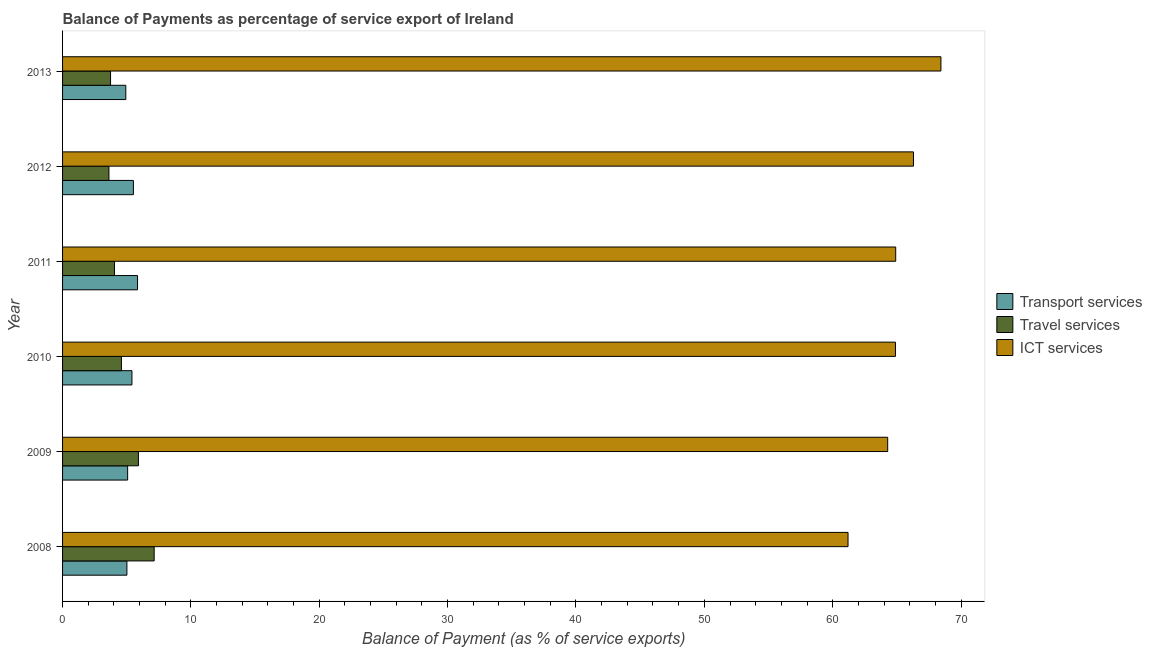How many different coloured bars are there?
Provide a short and direct response. 3. Are the number of bars per tick equal to the number of legend labels?
Your response must be concise. Yes. What is the label of the 2nd group of bars from the top?
Make the answer very short. 2012. What is the balance of payment of travel services in 2011?
Keep it short and to the point. 4.04. Across all years, what is the maximum balance of payment of transport services?
Make the answer very short. 5.84. Across all years, what is the minimum balance of payment of travel services?
Give a very brief answer. 3.61. In which year was the balance of payment of travel services minimum?
Provide a short and direct response. 2012. What is the total balance of payment of travel services in the graph?
Offer a very short reply. 29.03. What is the difference between the balance of payment of transport services in 2009 and that in 2013?
Provide a succinct answer. 0.14. What is the difference between the balance of payment of ict services in 2010 and the balance of payment of travel services in 2012?
Ensure brevity in your answer.  61.28. What is the average balance of payment of transport services per year?
Ensure brevity in your answer.  5.3. In the year 2010, what is the difference between the balance of payment of travel services and balance of payment of transport services?
Make the answer very short. -0.82. What is the ratio of the balance of payment of travel services in 2008 to that in 2010?
Your answer should be compact. 1.56. What is the difference between the highest and the second highest balance of payment of transport services?
Your response must be concise. 0.32. What is the difference between the highest and the lowest balance of payment of ict services?
Offer a very short reply. 7.24. In how many years, is the balance of payment of travel services greater than the average balance of payment of travel services taken over all years?
Give a very brief answer. 2. What does the 2nd bar from the top in 2010 represents?
Your answer should be compact. Travel services. What does the 3rd bar from the bottom in 2009 represents?
Keep it short and to the point. ICT services. How many bars are there?
Your answer should be very brief. 18. Are all the bars in the graph horizontal?
Keep it short and to the point. Yes. How are the legend labels stacked?
Your response must be concise. Vertical. What is the title of the graph?
Provide a succinct answer. Balance of Payments as percentage of service export of Ireland. What is the label or title of the X-axis?
Ensure brevity in your answer.  Balance of Payment (as % of service exports). What is the Balance of Payment (as % of service exports) in Transport services in 2008?
Provide a short and direct response. 5.01. What is the Balance of Payment (as % of service exports) of Travel services in 2008?
Keep it short and to the point. 7.14. What is the Balance of Payment (as % of service exports) of ICT services in 2008?
Give a very brief answer. 61.2. What is the Balance of Payment (as % of service exports) of Transport services in 2009?
Your answer should be very brief. 5.07. What is the Balance of Payment (as % of service exports) in Travel services in 2009?
Your response must be concise. 5.91. What is the Balance of Payment (as % of service exports) of ICT services in 2009?
Provide a succinct answer. 64.29. What is the Balance of Payment (as % of service exports) in Transport services in 2010?
Your answer should be very brief. 5.4. What is the Balance of Payment (as % of service exports) of Travel services in 2010?
Provide a succinct answer. 4.59. What is the Balance of Payment (as % of service exports) of ICT services in 2010?
Offer a terse response. 64.89. What is the Balance of Payment (as % of service exports) in Transport services in 2011?
Offer a terse response. 5.84. What is the Balance of Payment (as % of service exports) in Travel services in 2011?
Keep it short and to the point. 4.04. What is the Balance of Payment (as % of service exports) in ICT services in 2011?
Provide a short and direct response. 64.91. What is the Balance of Payment (as % of service exports) in Transport services in 2012?
Give a very brief answer. 5.52. What is the Balance of Payment (as % of service exports) in Travel services in 2012?
Make the answer very short. 3.61. What is the Balance of Payment (as % of service exports) of ICT services in 2012?
Your answer should be very brief. 66.3. What is the Balance of Payment (as % of service exports) of Transport services in 2013?
Your response must be concise. 4.93. What is the Balance of Payment (as % of service exports) of Travel services in 2013?
Offer a very short reply. 3.74. What is the Balance of Payment (as % of service exports) in ICT services in 2013?
Make the answer very short. 68.43. Across all years, what is the maximum Balance of Payment (as % of service exports) in Transport services?
Your response must be concise. 5.84. Across all years, what is the maximum Balance of Payment (as % of service exports) of Travel services?
Make the answer very short. 7.14. Across all years, what is the maximum Balance of Payment (as % of service exports) of ICT services?
Offer a very short reply. 68.43. Across all years, what is the minimum Balance of Payment (as % of service exports) of Transport services?
Offer a very short reply. 4.93. Across all years, what is the minimum Balance of Payment (as % of service exports) of Travel services?
Provide a succinct answer. 3.61. Across all years, what is the minimum Balance of Payment (as % of service exports) of ICT services?
Your answer should be very brief. 61.2. What is the total Balance of Payment (as % of service exports) in Transport services in the graph?
Offer a very short reply. 31.77. What is the total Balance of Payment (as % of service exports) of Travel services in the graph?
Provide a short and direct response. 29.03. What is the total Balance of Payment (as % of service exports) in ICT services in the graph?
Your answer should be very brief. 390.01. What is the difference between the Balance of Payment (as % of service exports) of Transport services in 2008 and that in 2009?
Keep it short and to the point. -0.06. What is the difference between the Balance of Payment (as % of service exports) in Travel services in 2008 and that in 2009?
Your response must be concise. 1.23. What is the difference between the Balance of Payment (as % of service exports) in ICT services in 2008 and that in 2009?
Your answer should be compact. -3.09. What is the difference between the Balance of Payment (as % of service exports) in Transport services in 2008 and that in 2010?
Ensure brevity in your answer.  -0.39. What is the difference between the Balance of Payment (as % of service exports) of Travel services in 2008 and that in 2010?
Give a very brief answer. 2.55. What is the difference between the Balance of Payment (as % of service exports) of ICT services in 2008 and that in 2010?
Your answer should be compact. -3.7. What is the difference between the Balance of Payment (as % of service exports) of Transport services in 2008 and that in 2011?
Make the answer very short. -0.83. What is the difference between the Balance of Payment (as % of service exports) of Travel services in 2008 and that in 2011?
Provide a succinct answer. 3.09. What is the difference between the Balance of Payment (as % of service exports) in ICT services in 2008 and that in 2011?
Offer a terse response. -3.71. What is the difference between the Balance of Payment (as % of service exports) in Transport services in 2008 and that in 2012?
Provide a short and direct response. -0.51. What is the difference between the Balance of Payment (as % of service exports) of Travel services in 2008 and that in 2012?
Ensure brevity in your answer.  3.52. What is the difference between the Balance of Payment (as % of service exports) in ICT services in 2008 and that in 2012?
Offer a very short reply. -5.1. What is the difference between the Balance of Payment (as % of service exports) of Transport services in 2008 and that in 2013?
Your answer should be very brief. 0.09. What is the difference between the Balance of Payment (as % of service exports) in Travel services in 2008 and that in 2013?
Ensure brevity in your answer.  3.4. What is the difference between the Balance of Payment (as % of service exports) of ICT services in 2008 and that in 2013?
Keep it short and to the point. -7.24. What is the difference between the Balance of Payment (as % of service exports) of Transport services in 2009 and that in 2010?
Provide a short and direct response. -0.33. What is the difference between the Balance of Payment (as % of service exports) in Travel services in 2009 and that in 2010?
Keep it short and to the point. 1.32. What is the difference between the Balance of Payment (as % of service exports) of ICT services in 2009 and that in 2010?
Your response must be concise. -0.61. What is the difference between the Balance of Payment (as % of service exports) in Transport services in 2009 and that in 2011?
Provide a short and direct response. -0.77. What is the difference between the Balance of Payment (as % of service exports) in Travel services in 2009 and that in 2011?
Make the answer very short. 1.86. What is the difference between the Balance of Payment (as % of service exports) of ICT services in 2009 and that in 2011?
Offer a very short reply. -0.62. What is the difference between the Balance of Payment (as % of service exports) of Transport services in 2009 and that in 2012?
Your response must be concise. -0.45. What is the difference between the Balance of Payment (as % of service exports) of Travel services in 2009 and that in 2012?
Keep it short and to the point. 2.3. What is the difference between the Balance of Payment (as % of service exports) in ICT services in 2009 and that in 2012?
Provide a short and direct response. -2.01. What is the difference between the Balance of Payment (as % of service exports) in Transport services in 2009 and that in 2013?
Make the answer very short. 0.14. What is the difference between the Balance of Payment (as % of service exports) in Travel services in 2009 and that in 2013?
Provide a succinct answer. 2.17. What is the difference between the Balance of Payment (as % of service exports) of ICT services in 2009 and that in 2013?
Make the answer very short. -4.15. What is the difference between the Balance of Payment (as % of service exports) in Transport services in 2010 and that in 2011?
Give a very brief answer. -0.44. What is the difference between the Balance of Payment (as % of service exports) in Travel services in 2010 and that in 2011?
Your answer should be compact. 0.54. What is the difference between the Balance of Payment (as % of service exports) in ICT services in 2010 and that in 2011?
Keep it short and to the point. -0.02. What is the difference between the Balance of Payment (as % of service exports) in Transport services in 2010 and that in 2012?
Offer a terse response. -0.11. What is the difference between the Balance of Payment (as % of service exports) of Travel services in 2010 and that in 2012?
Offer a very short reply. 0.97. What is the difference between the Balance of Payment (as % of service exports) of ICT services in 2010 and that in 2012?
Ensure brevity in your answer.  -1.4. What is the difference between the Balance of Payment (as % of service exports) in Transport services in 2010 and that in 2013?
Keep it short and to the point. 0.48. What is the difference between the Balance of Payment (as % of service exports) of Travel services in 2010 and that in 2013?
Make the answer very short. 0.85. What is the difference between the Balance of Payment (as % of service exports) of ICT services in 2010 and that in 2013?
Your answer should be compact. -3.54. What is the difference between the Balance of Payment (as % of service exports) in Transport services in 2011 and that in 2012?
Your answer should be compact. 0.32. What is the difference between the Balance of Payment (as % of service exports) of Travel services in 2011 and that in 2012?
Offer a terse response. 0.43. What is the difference between the Balance of Payment (as % of service exports) in ICT services in 2011 and that in 2012?
Your response must be concise. -1.38. What is the difference between the Balance of Payment (as % of service exports) of Transport services in 2011 and that in 2013?
Your answer should be compact. 0.91. What is the difference between the Balance of Payment (as % of service exports) of Travel services in 2011 and that in 2013?
Your response must be concise. 0.31. What is the difference between the Balance of Payment (as % of service exports) of ICT services in 2011 and that in 2013?
Ensure brevity in your answer.  -3.52. What is the difference between the Balance of Payment (as % of service exports) in Transport services in 2012 and that in 2013?
Your answer should be compact. 0.59. What is the difference between the Balance of Payment (as % of service exports) of Travel services in 2012 and that in 2013?
Provide a short and direct response. -0.13. What is the difference between the Balance of Payment (as % of service exports) of ICT services in 2012 and that in 2013?
Provide a succinct answer. -2.14. What is the difference between the Balance of Payment (as % of service exports) of Transport services in 2008 and the Balance of Payment (as % of service exports) of Travel services in 2009?
Offer a terse response. -0.9. What is the difference between the Balance of Payment (as % of service exports) in Transport services in 2008 and the Balance of Payment (as % of service exports) in ICT services in 2009?
Keep it short and to the point. -59.27. What is the difference between the Balance of Payment (as % of service exports) in Travel services in 2008 and the Balance of Payment (as % of service exports) in ICT services in 2009?
Your answer should be very brief. -57.15. What is the difference between the Balance of Payment (as % of service exports) of Transport services in 2008 and the Balance of Payment (as % of service exports) of Travel services in 2010?
Keep it short and to the point. 0.43. What is the difference between the Balance of Payment (as % of service exports) in Transport services in 2008 and the Balance of Payment (as % of service exports) in ICT services in 2010?
Your response must be concise. -59.88. What is the difference between the Balance of Payment (as % of service exports) in Travel services in 2008 and the Balance of Payment (as % of service exports) in ICT services in 2010?
Offer a terse response. -57.76. What is the difference between the Balance of Payment (as % of service exports) of Transport services in 2008 and the Balance of Payment (as % of service exports) of Travel services in 2011?
Provide a succinct answer. 0.97. What is the difference between the Balance of Payment (as % of service exports) of Transport services in 2008 and the Balance of Payment (as % of service exports) of ICT services in 2011?
Ensure brevity in your answer.  -59.9. What is the difference between the Balance of Payment (as % of service exports) in Travel services in 2008 and the Balance of Payment (as % of service exports) in ICT services in 2011?
Your answer should be compact. -57.77. What is the difference between the Balance of Payment (as % of service exports) of Transport services in 2008 and the Balance of Payment (as % of service exports) of Travel services in 2012?
Ensure brevity in your answer.  1.4. What is the difference between the Balance of Payment (as % of service exports) in Transport services in 2008 and the Balance of Payment (as % of service exports) in ICT services in 2012?
Ensure brevity in your answer.  -61.28. What is the difference between the Balance of Payment (as % of service exports) of Travel services in 2008 and the Balance of Payment (as % of service exports) of ICT services in 2012?
Your response must be concise. -59.16. What is the difference between the Balance of Payment (as % of service exports) of Transport services in 2008 and the Balance of Payment (as % of service exports) of Travel services in 2013?
Ensure brevity in your answer.  1.27. What is the difference between the Balance of Payment (as % of service exports) in Transport services in 2008 and the Balance of Payment (as % of service exports) in ICT services in 2013?
Provide a short and direct response. -63.42. What is the difference between the Balance of Payment (as % of service exports) of Travel services in 2008 and the Balance of Payment (as % of service exports) of ICT services in 2013?
Offer a very short reply. -61.3. What is the difference between the Balance of Payment (as % of service exports) in Transport services in 2009 and the Balance of Payment (as % of service exports) in Travel services in 2010?
Your answer should be compact. 0.48. What is the difference between the Balance of Payment (as % of service exports) of Transport services in 2009 and the Balance of Payment (as % of service exports) of ICT services in 2010?
Ensure brevity in your answer.  -59.82. What is the difference between the Balance of Payment (as % of service exports) in Travel services in 2009 and the Balance of Payment (as % of service exports) in ICT services in 2010?
Your answer should be very brief. -58.98. What is the difference between the Balance of Payment (as % of service exports) in Transport services in 2009 and the Balance of Payment (as % of service exports) in Travel services in 2011?
Your answer should be very brief. 1.03. What is the difference between the Balance of Payment (as % of service exports) of Transport services in 2009 and the Balance of Payment (as % of service exports) of ICT services in 2011?
Make the answer very short. -59.84. What is the difference between the Balance of Payment (as % of service exports) in Travel services in 2009 and the Balance of Payment (as % of service exports) in ICT services in 2011?
Give a very brief answer. -59. What is the difference between the Balance of Payment (as % of service exports) of Transport services in 2009 and the Balance of Payment (as % of service exports) of Travel services in 2012?
Provide a succinct answer. 1.46. What is the difference between the Balance of Payment (as % of service exports) of Transport services in 2009 and the Balance of Payment (as % of service exports) of ICT services in 2012?
Offer a very short reply. -61.22. What is the difference between the Balance of Payment (as % of service exports) of Travel services in 2009 and the Balance of Payment (as % of service exports) of ICT services in 2012?
Give a very brief answer. -60.39. What is the difference between the Balance of Payment (as % of service exports) in Transport services in 2009 and the Balance of Payment (as % of service exports) in Travel services in 2013?
Your answer should be compact. 1.33. What is the difference between the Balance of Payment (as % of service exports) in Transport services in 2009 and the Balance of Payment (as % of service exports) in ICT services in 2013?
Provide a short and direct response. -63.36. What is the difference between the Balance of Payment (as % of service exports) of Travel services in 2009 and the Balance of Payment (as % of service exports) of ICT services in 2013?
Ensure brevity in your answer.  -62.52. What is the difference between the Balance of Payment (as % of service exports) of Transport services in 2010 and the Balance of Payment (as % of service exports) of Travel services in 2011?
Offer a very short reply. 1.36. What is the difference between the Balance of Payment (as % of service exports) of Transport services in 2010 and the Balance of Payment (as % of service exports) of ICT services in 2011?
Provide a short and direct response. -59.51. What is the difference between the Balance of Payment (as % of service exports) of Travel services in 2010 and the Balance of Payment (as % of service exports) of ICT services in 2011?
Offer a very short reply. -60.32. What is the difference between the Balance of Payment (as % of service exports) of Transport services in 2010 and the Balance of Payment (as % of service exports) of Travel services in 2012?
Ensure brevity in your answer.  1.79. What is the difference between the Balance of Payment (as % of service exports) of Transport services in 2010 and the Balance of Payment (as % of service exports) of ICT services in 2012?
Give a very brief answer. -60.89. What is the difference between the Balance of Payment (as % of service exports) of Travel services in 2010 and the Balance of Payment (as % of service exports) of ICT services in 2012?
Provide a short and direct response. -61.71. What is the difference between the Balance of Payment (as % of service exports) in Transport services in 2010 and the Balance of Payment (as % of service exports) in Travel services in 2013?
Offer a very short reply. 1.67. What is the difference between the Balance of Payment (as % of service exports) of Transport services in 2010 and the Balance of Payment (as % of service exports) of ICT services in 2013?
Your response must be concise. -63.03. What is the difference between the Balance of Payment (as % of service exports) in Travel services in 2010 and the Balance of Payment (as % of service exports) in ICT services in 2013?
Make the answer very short. -63.85. What is the difference between the Balance of Payment (as % of service exports) of Transport services in 2011 and the Balance of Payment (as % of service exports) of Travel services in 2012?
Offer a terse response. 2.23. What is the difference between the Balance of Payment (as % of service exports) in Transport services in 2011 and the Balance of Payment (as % of service exports) in ICT services in 2012?
Provide a short and direct response. -60.45. What is the difference between the Balance of Payment (as % of service exports) in Travel services in 2011 and the Balance of Payment (as % of service exports) in ICT services in 2012?
Ensure brevity in your answer.  -62.25. What is the difference between the Balance of Payment (as % of service exports) of Transport services in 2011 and the Balance of Payment (as % of service exports) of Travel services in 2013?
Make the answer very short. 2.1. What is the difference between the Balance of Payment (as % of service exports) in Transport services in 2011 and the Balance of Payment (as % of service exports) in ICT services in 2013?
Provide a succinct answer. -62.59. What is the difference between the Balance of Payment (as % of service exports) of Travel services in 2011 and the Balance of Payment (as % of service exports) of ICT services in 2013?
Make the answer very short. -64.39. What is the difference between the Balance of Payment (as % of service exports) in Transport services in 2012 and the Balance of Payment (as % of service exports) in Travel services in 2013?
Keep it short and to the point. 1.78. What is the difference between the Balance of Payment (as % of service exports) in Transport services in 2012 and the Balance of Payment (as % of service exports) in ICT services in 2013?
Your answer should be compact. -62.91. What is the difference between the Balance of Payment (as % of service exports) in Travel services in 2012 and the Balance of Payment (as % of service exports) in ICT services in 2013?
Your response must be concise. -64.82. What is the average Balance of Payment (as % of service exports) of Transport services per year?
Your answer should be very brief. 5.3. What is the average Balance of Payment (as % of service exports) in Travel services per year?
Offer a very short reply. 4.84. What is the average Balance of Payment (as % of service exports) in ICT services per year?
Ensure brevity in your answer.  65. In the year 2008, what is the difference between the Balance of Payment (as % of service exports) of Transport services and Balance of Payment (as % of service exports) of Travel services?
Make the answer very short. -2.12. In the year 2008, what is the difference between the Balance of Payment (as % of service exports) in Transport services and Balance of Payment (as % of service exports) in ICT services?
Ensure brevity in your answer.  -56.18. In the year 2008, what is the difference between the Balance of Payment (as % of service exports) in Travel services and Balance of Payment (as % of service exports) in ICT services?
Provide a short and direct response. -54.06. In the year 2009, what is the difference between the Balance of Payment (as % of service exports) in Transport services and Balance of Payment (as % of service exports) in Travel services?
Keep it short and to the point. -0.84. In the year 2009, what is the difference between the Balance of Payment (as % of service exports) of Transport services and Balance of Payment (as % of service exports) of ICT services?
Your response must be concise. -59.22. In the year 2009, what is the difference between the Balance of Payment (as % of service exports) of Travel services and Balance of Payment (as % of service exports) of ICT services?
Your response must be concise. -58.38. In the year 2010, what is the difference between the Balance of Payment (as % of service exports) in Transport services and Balance of Payment (as % of service exports) in Travel services?
Make the answer very short. 0.82. In the year 2010, what is the difference between the Balance of Payment (as % of service exports) of Transport services and Balance of Payment (as % of service exports) of ICT services?
Give a very brief answer. -59.49. In the year 2010, what is the difference between the Balance of Payment (as % of service exports) in Travel services and Balance of Payment (as % of service exports) in ICT services?
Ensure brevity in your answer.  -60.31. In the year 2011, what is the difference between the Balance of Payment (as % of service exports) in Transport services and Balance of Payment (as % of service exports) in Travel services?
Ensure brevity in your answer.  1.8. In the year 2011, what is the difference between the Balance of Payment (as % of service exports) in Transport services and Balance of Payment (as % of service exports) in ICT services?
Keep it short and to the point. -59.07. In the year 2011, what is the difference between the Balance of Payment (as % of service exports) of Travel services and Balance of Payment (as % of service exports) of ICT services?
Provide a succinct answer. -60.87. In the year 2012, what is the difference between the Balance of Payment (as % of service exports) in Transport services and Balance of Payment (as % of service exports) in Travel services?
Offer a very short reply. 1.91. In the year 2012, what is the difference between the Balance of Payment (as % of service exports) of Transport services and Balance of Payment (as % of service exports) of ICT services?
Your response must be concise. -60.78. In the year 2012, what is the difference between the Balance of Payment (as % of service exports) of Travel services and Balance of Payment (as % of service exports) of ICT services?
Your response must be concise. -62.68. In the year 2013, what is the difference between the Balance of Payment (as % of service exports) of Transport services and Balance of Payment (as % of service exports) of Travel services?
Give a very brief answer. 1.19. In the year 2013, what is the difference between the Balance of Payment (as % of service exports) in Transport services and Balance of Payment (as % of service exports) in ICT services?
Your answer should be compact. -63.51. In the year 2013, what is the difference between the Balance of Payment (as % of service exports) of Travel services and Balance of Payment (as % of service exports) of ICT services?
Your answer should be very brief. -64.7. What is the ratio of the Balance of Payment (as % of service exports) in Transport services in 2008 to that in 2009?
Your answer should be compact. 0.99. What is the ratio of the Balance of Payment (as % of service exports) of Travel services in 2008 to that in 2009?
Keep it short and to the point. 1.21. What is the ratio of the Balance of Payment (as % of service exports) of ICT services in 2008 to that in 2009?
Offer a terse response. 0.95. What is the ratio of the Balance of Payment (as % of service exports) of Transport services in 2008 to that in 2010?
Your response must be concise. 0.93. What is the ratio of the Balance of Payment (as % of service exports) of Travel services in 2008 to that in 2010?
Provide a succinct answer. 1.56. What is the ratio of the Balance of Payment (as % of service exports) in ICT services in 2008 to that in 2010?
Your answer should be very brief. 0.94. What is the ratio of the Balance of Payment (as % of service exports) of Transport services in 2008 to that in 2011?
Give a very brief answer. 0.86. What is the ratio of the Balance of Payment (as % of service exports) in Travel services in 2008 to that in 2011?
Your response must be concise. 1.76. What is the ratio of the Balance of Payment (as % of service exports) of ICT services in 2008 to that in 2011?
Keep it short and to the point. 0.94. What is the ratio of the Balance of Payment (as % of service exports) in Transport services in 2008 to that in 2012?
Your answer should be compact. 0.91. What is the ratio of the Balance of Payment (as % of service exports) in Travel services in 2008 to that in 2012?
Provide a short and direct response. 1.98. What is the ratio of the Balance of Payment (as % of service exports) in Transport services in 2008 to that in 2013?
Your answer should be very brief. 1.02. What is the ratio of the Balance of Payment (as % of service exports) of Travel services in 2008 to that in 2013?
Your answer should be compact. 1.91. What is the ratio of the Balance of Payment (as % of service exports) in ICT services in 2008 to that in 2013?
Provide a short and direct response. 0.89. What is the ratio of the Balance of Payment (as % of service exports) of Transport services in 2009 to that in 2010?
Give a very brief answer. 0.94. What is the ratio of the Balance of Payment (as % of service exports) in Travel services in 2009 to that in 2010?
Provide a succinct answer. 1.29. What is the ratio of the Balance of Payment (as % of service exports) in Transport services in 2009 to that in 2011?
Offer a very short reply. 0.87. What is the ratio of the Balance of Payment (as % of service exports) of Travel services in 2009 to that in 2011?
Ensure brevity in your answer.  1.46. What is the ratio of the Balance of Payment (as % of service exports) in ICT services in 2009 to that in 2011?
Offer a terse response. 0.99. What is the ratio of the Balance of Payment (as % of service exports) of Transport services in 2009 to that in 2012?
Give a very brief answer. 0.92. What is the ratio of the Balance of Payment (as % of service exports) of Travel services in 2009 to that in 2012?
Make the answer very short. 1.64. What is the ratio of the Balance of Payment (as % of service exports) in ICT services in 2009 to that in 2012?
Keep it short and to the point. 0.97. What is the ratio of the Balance of Payment (as % of service exports) of Travel services in 2009 to that in 2013?
Your answer should be very brief. 1.58. What is the ratio of the Balance of Payment (as % of service exports) in ICT services in 2009 to that in 2013?
Your answer should be compact. 0.94. What is the ratio of the Balance of Payment (as % of service exports) of Transport services in 2010 to that in 2011?
Your response must be concise. 0.93. What is the ratio of the Balance of Payment (as % of service exports) in Travel services in 2010 to that in 2011?
Provide a short and direct response. 1.13. What is the ratio of the Balance of Payment (as % of service exports) of Transport services in 2010 to that in 2012?
Keep it short and to the point. 0.98. What is the ratio of the Balance of Payment (as % of service exports) of Travel services in 2010 to that in 2012?
Offer a very short reply. 1.27. What is the ratio of the Balance of Payment (as % of service exports) in ICT services in 2010 to that in 2012?
Your answer should be very brief. 0.98. What is the ratio of the Balance of Payment (as % of service exports) in Transport services in 2010 to that in 2013?
Give a very brief answer. 1.1. What is the ratio of the Balance of Payment (as % of service exports) of Travel services in 2010 to that in 2013?
Give a very brief answer. 1.23. What is the ratio of the Balance of Payment (as % of service exports) of ICT services in 2010 to that in 2013?
Offer a terse response. 0.95. What is the ratio of the Balance of Payment (as % of service exports) in Transport services in 2011 to that in 2012?
Keep it short and to the point. 1.06. What is the ratio of the Balance of Payment (as % of service exports) of Travel services in 2011 to that in 2012?
Make the answer very short. 1.12. What is the ratio of the Balance of Payment (as % of service exports) of ICT services in 2011 to that in 2012?
Offer a very short reply. 0.98. What is the ratio of the Balance of Payment (as % of service exports) of Transport services in 2011 to that in 2013?
Give a very brief answer. 1.19. What is the ratio of the Balance of Payment (as % of service exports) of Travel services in 2011 to that in 2013?
Ensure brevity in your answer.  1.08. What is the ratio of the Balance of Payment (as % of service exports) of ICT services in 2011 to that in 2013?
Ensure brevity in your answer.  0.95. What is the ratio of the Balance of Payment (as % of service exports) of Transport services in 2012 to that in 2013?
Offer a very short reply. 1.12. What is the ratio of the Balance of Payment (as % of service exports) of Travel services in 2012 to that in 2013?
Ensure brevity in your answer.  0.97. What is the ratio of the Balance of Payment (as % of service exports) of ICT services in 2012 to that in 2013?
Offer a terse response. 0.97. What is the difference between the highest and the second highest Balance of Payment (as % of service exports) in Transport services?
Offer a very short reply. 0.32. What is the difference between the highest and the second highest Balance of Payment (as % of service exports) in Travel services?
Give a very brief answer. 1.23. What is the difference between the highest and the second highest Balance of Payment (as % of service exports) of ICT services?
Your answer should be very brief. 2.14. What is the difference between the highest and the lowest Balance of Payment (as % of service exports) in Transport services?
Ensure brevity in your answer.  0.91. What is the difference between the highest and the lowest Balance of Payment (as % of service exports) in Travel services?
Ensure brevity in your answer.  3.52. What is the difference between the highest and the lowest Balance of Payment (as % of service exports) of ICT services?
Your answer should be very brief. 7.24. 